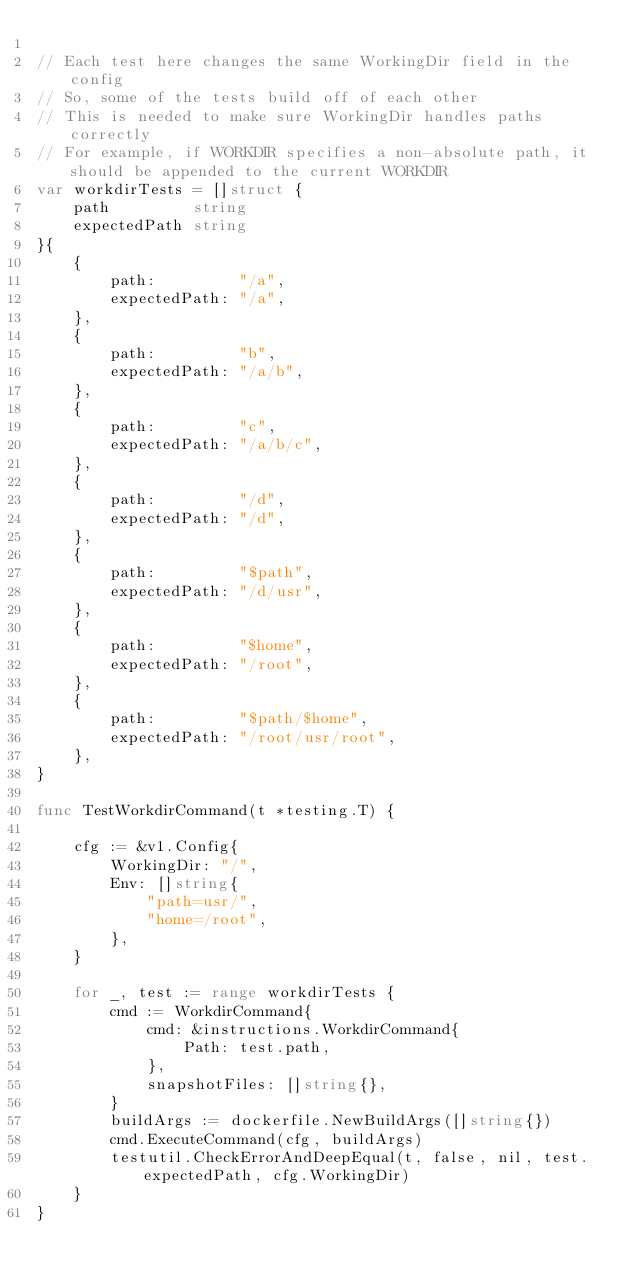<code> <loc_0><loc_0><loc_500><loc_500><_Go_>
// Each test here changes the same WorkingDir field in the config
// So, some of the tests build off of each other
// This is needed to make sure WorkingDir handles paths correctly
// For example, if WORKDIR specifies a non-absolute path, it should be appended to the current WORKDIR
var workdirTests = []struct {
	path         string
	expectedPath string
}{
	{
		path:         "/a",
		expectedPath: "/a",
	},
	{
		path:         "b",
		expectedPath: "/a/b",
	},
	{
		path:         "c",
		expectedPath: "/a/b/c",
	},
	{
		path:         "/d",
		expectedPath: "/d",
	},
	{
		path:         "$path",
		expectedPath: "/d/usr",
	},
	{
		path:         "$home",
		expectedPath: "/root",
	},
	{
		path:         "$path/$home",
		expectedPath: "/root/usr/root",
	},
}

func TestWorkdirCommand(t *testing.T) {

	cfg := &v1.Config{
		WorkingDir: "/",
		Env: []string{
			"path=usr/",
			"home=/root",
		},
	}

	for _, test := range workdirTests {
		cmd := WorkdirCommand{
			cmd: &instructions.WorkdirCommand{
				Path: test.path,
			},
			snapshotFiles: []string{},
		}
		buildArgs := dockerfile.NewBuildArgs([]string{})
		cmd.ExecuteCommand(cfg, buildArgs)
		testutil.CheckErrorAndDeepEqual(t, false, nil, test.expectedPath, cfg.WorkingDir)
	}
}
</code> 